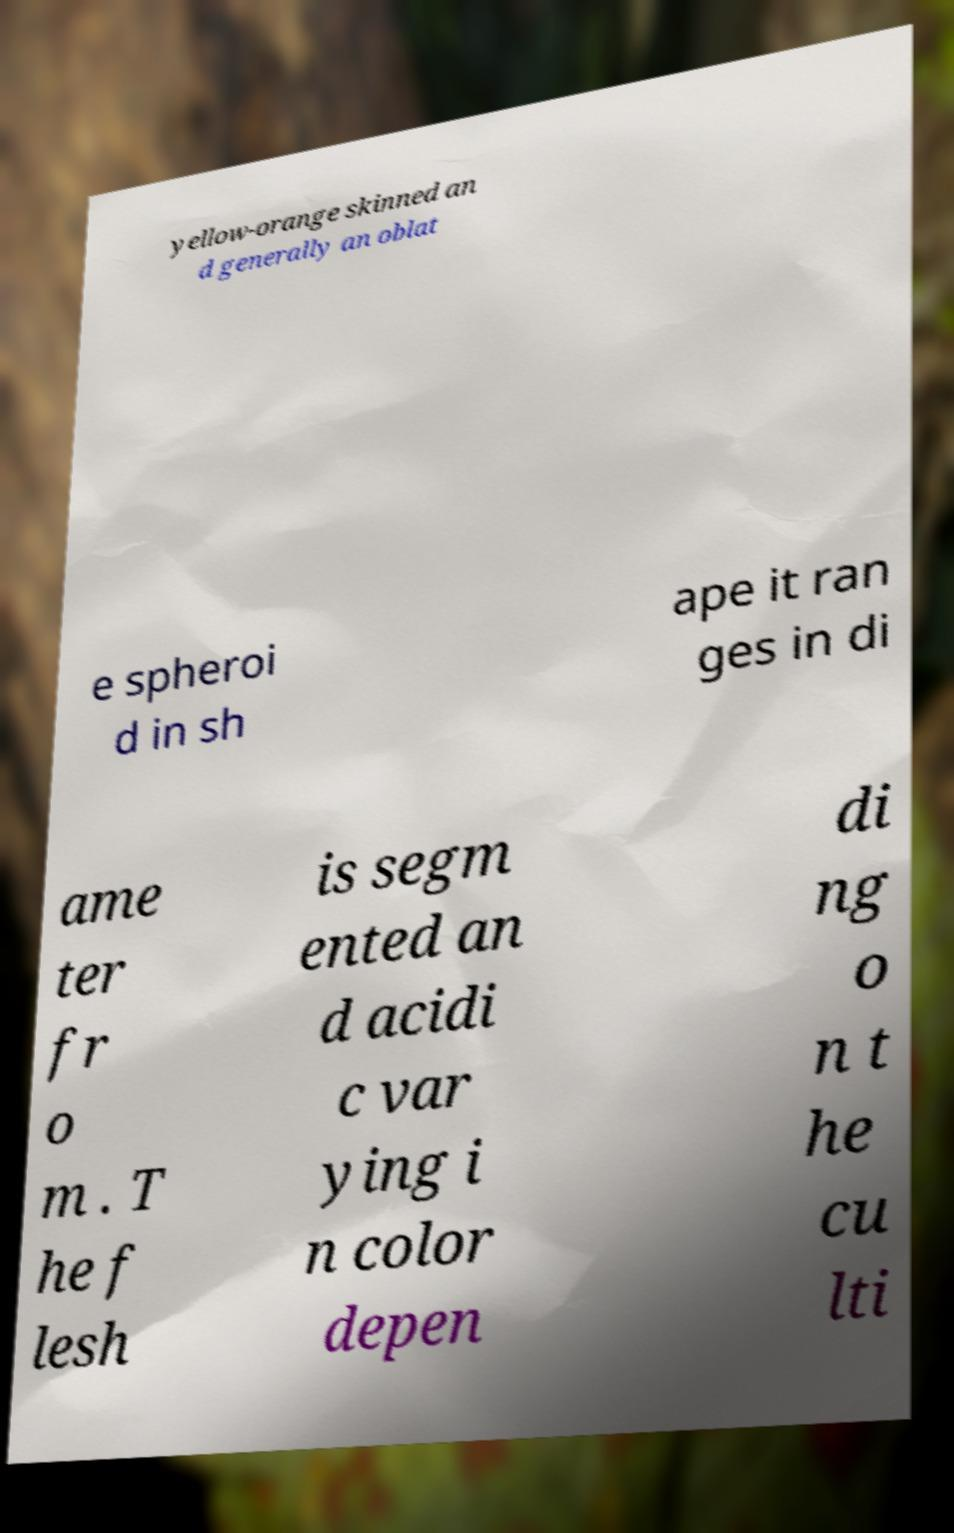Please read and relay the text visible in this image. What does it say? yellow-orange skinned an d generally an oblat e spheroi d in sh ape it ran ges in di ame ter fr o m . T he f lesh is segm ented an d acidi c var ying i n color depen di ng o n t he cu lti 